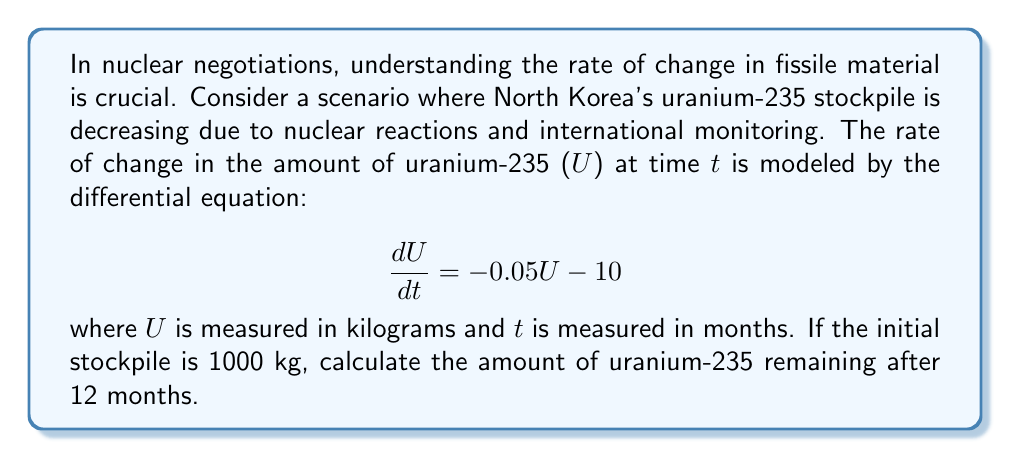Provide a solution to this math problem. To solve this problem, we need to use the technique for solving first-order linear differential equations. The general form of such equations is:

$$\frac{dy}{dx} + P(x)y = Q(x)$$

In our case, we have:

$$\frac{dU}{dt} + 0.05U = -10$$

Step 1: Find the integrating factor
The integrating factor is $e^{\int P(x)dx}$. Here, $P(t) = 0.05$, so:

$$\mu(t) = e^{\int 0.05 dt} = e^{0.05t}$$

Step 2: Multiply both sides of the equation by the integrating factor

$$(e^{0.05t}\frac{dU}{dt}) + (0.05e^{0.05t}U) = -10e^{0.05t}$$

Step 3: Recognize that the left side is the derivative of $e^{0.05t}U$

$$\frac{d}{dt}(e^{0.05t}U) = -10e^{0.05t}$$

Step 4: Integrate both sides

$$e^{0.05t}U = -\frac{10}{0.05}e^{0.05t} + C$$

Step 5: Solve for U

$$U = -200 + Ce^{-0.05t}$$

Step 6: Use the initial condition to find C
At $t=0$, $U = 1000$, so:

$$1000 = -200 + C$$
$$C = 1200$$

Therefore, the general solution is:

$$U = -200 + 1200e^{-0.05t}$$

Step 7: Calculate U at t = 12 months

$$U(12) = -200 + 1200e^{-0.05(12)}$$
$$U(12) = -200 + 1200(0.5488)$$
$$U(12) = 458.56$$
Answer: The amount of uranium-235 remaining after 12 months is approximately 458.56 kg. 